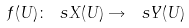Convert formula to latex. <formula><loc_0><loc_0><loc_500><loc_500>f ( U ) \colon \ s X ( U ) \rightarrow \ s Y ( U )</formula> 